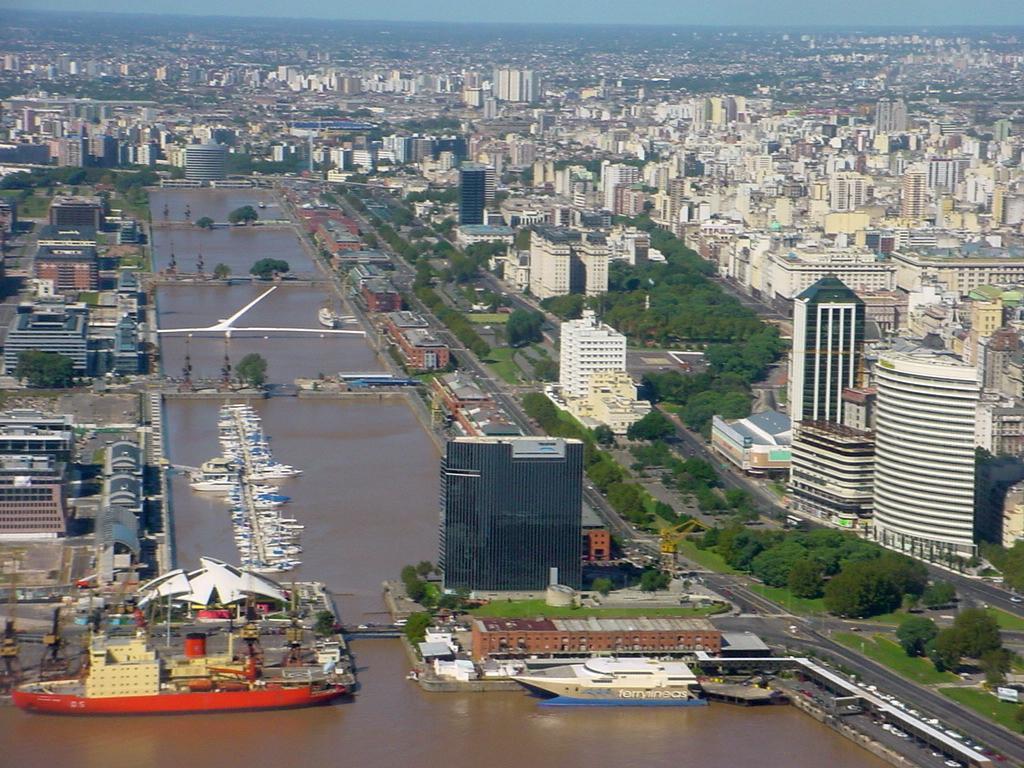Could you give a brief overview of what you see in this image? In this image in the center there are some buildings and trees and a walkway, and in the center there is a sea. In that sea there are some boats, and in the background there are some buildings. 